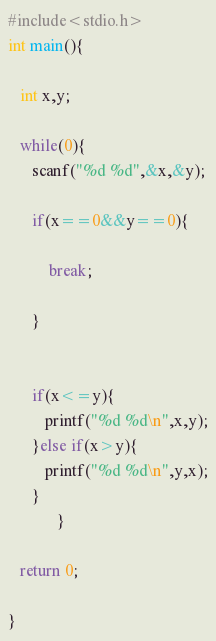Convert code to text. <code><loc_0><loc_0><loc_500><loc_500><_C++_>#include<stdio.h>
int main(){

   int x,y;

   while(0){
      scanf("%d %d",&x,&y);

      if(x==0&&y==0){

          break;

      }


      if(x<=y){
         printf("%d %d\n",x,y);
      }else if(x>y){
         printf("%d %d\n",y,x);
      }
            }

   return 0;

}</code> 